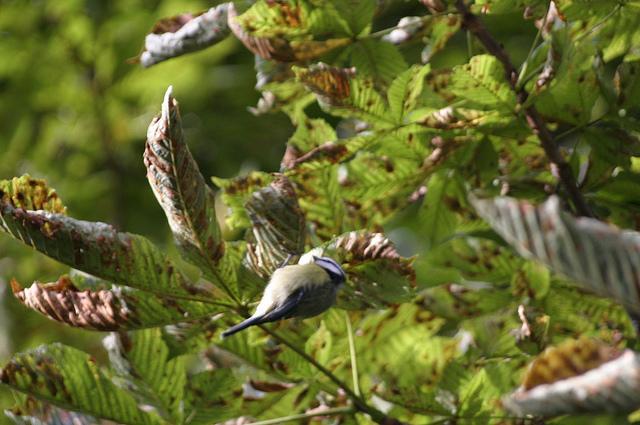Is the bird upside down?
Short answer required. No. What is the shape of the object the bird is perched on?
Answer briefly. Stick. Is this animal a mammal?
Give a very brief answer. No. What covers the tree branch?
Concise answer only. Leaves. What is the bird sitting on?
Answer briefly. Branch. What is the bird  standing on?
Keep it brief. Branch. Why are some of the leaves brown?
Concise answer only. Dying. What two things look alike?
Be succinct. Leaves. 